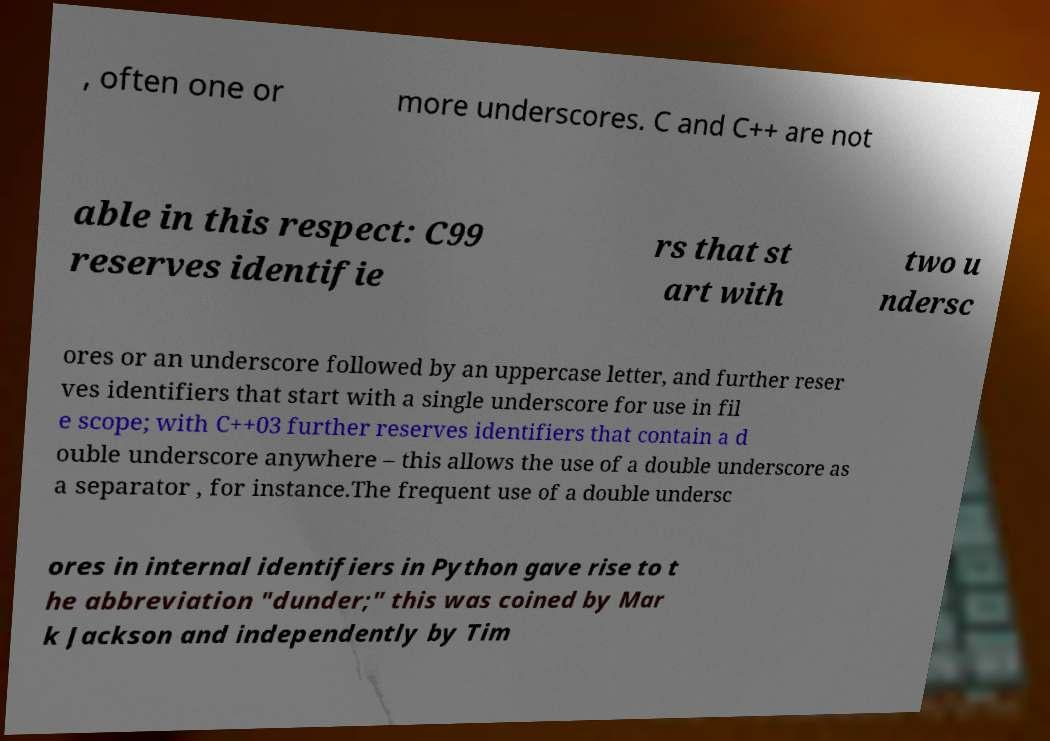Can you read and provide the text displayed in the image?This photo seems to have some interesting text. Can you extract and type it out for me? , often one or more underscores. C and C++ are not able in this respect: C99 reserves identifie rs that st art with two u ndersc ores or an underscore followed by an uppercase letter, and further reser ves identifiers that start with a single underscore for use in fil e scope; with C++03 further reserves identifiers that contain a d ouble underscore anywhere – this allows the use of a double underscore as a separator , for instance.The frequent use of a double undersc ores in internal identifiers in Python gave rise to t he abbreviation "dunder;" this was coined by Mar k Jackson and independently by Tim 